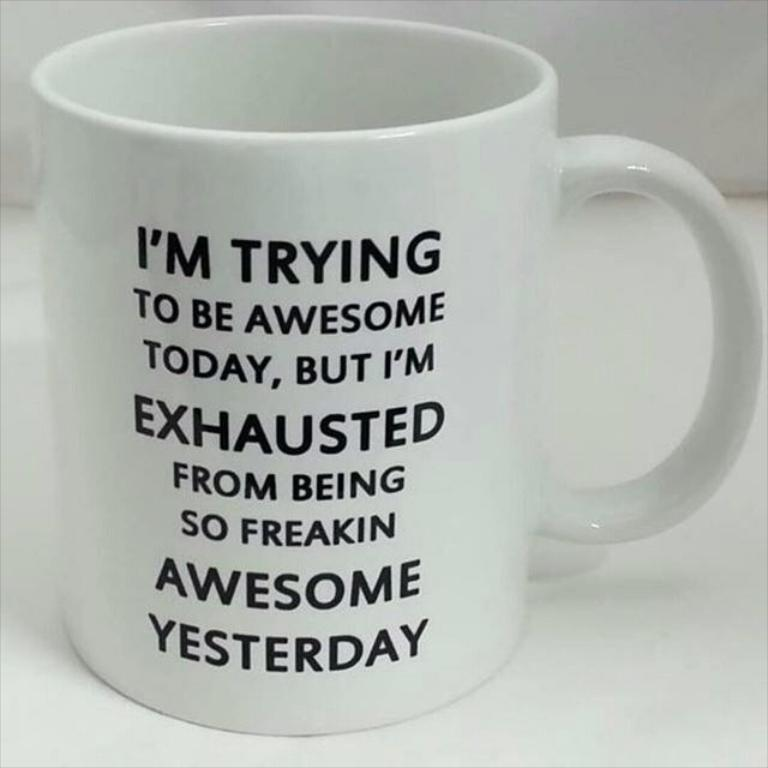Provide a one-sentence caption for the provided image. The object is a large coffee mug with a funny saying written in black and all caps. 